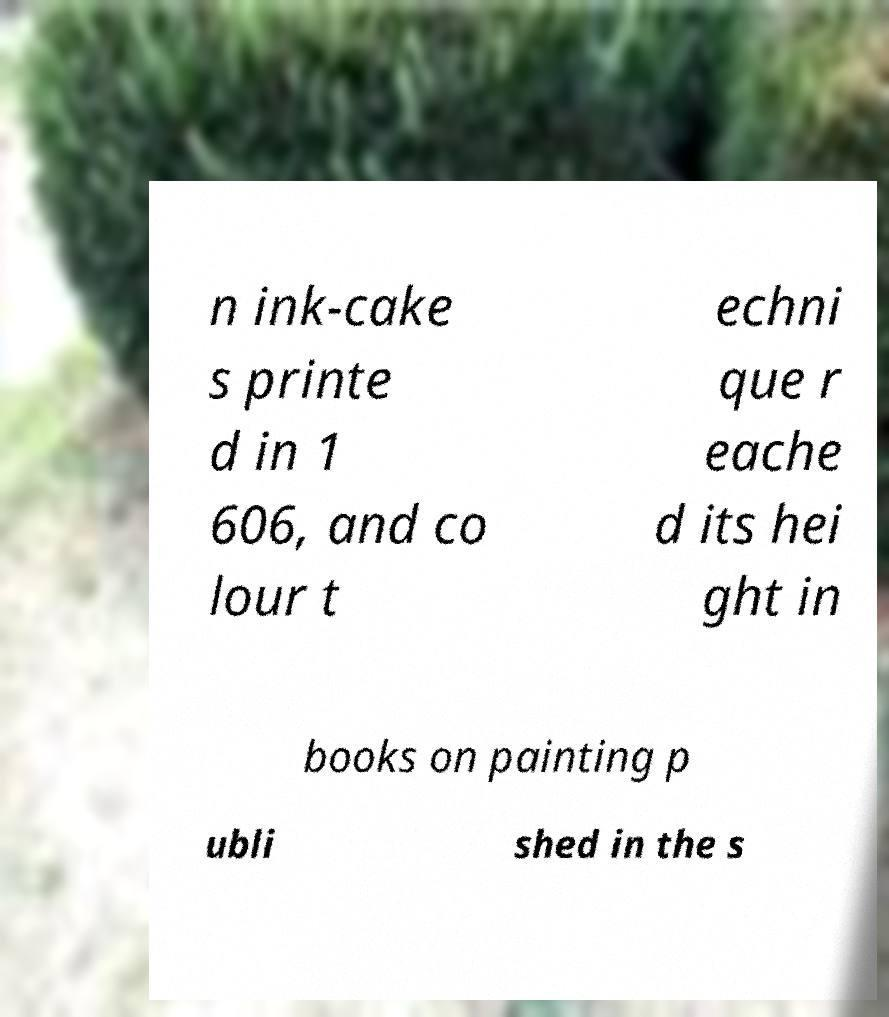Please identify and transcribe the text found in this image. n ink-cake s printe d in 1 606, and co lour t echni que r eache d its hei ght in books on painting p ubli shed in the s 